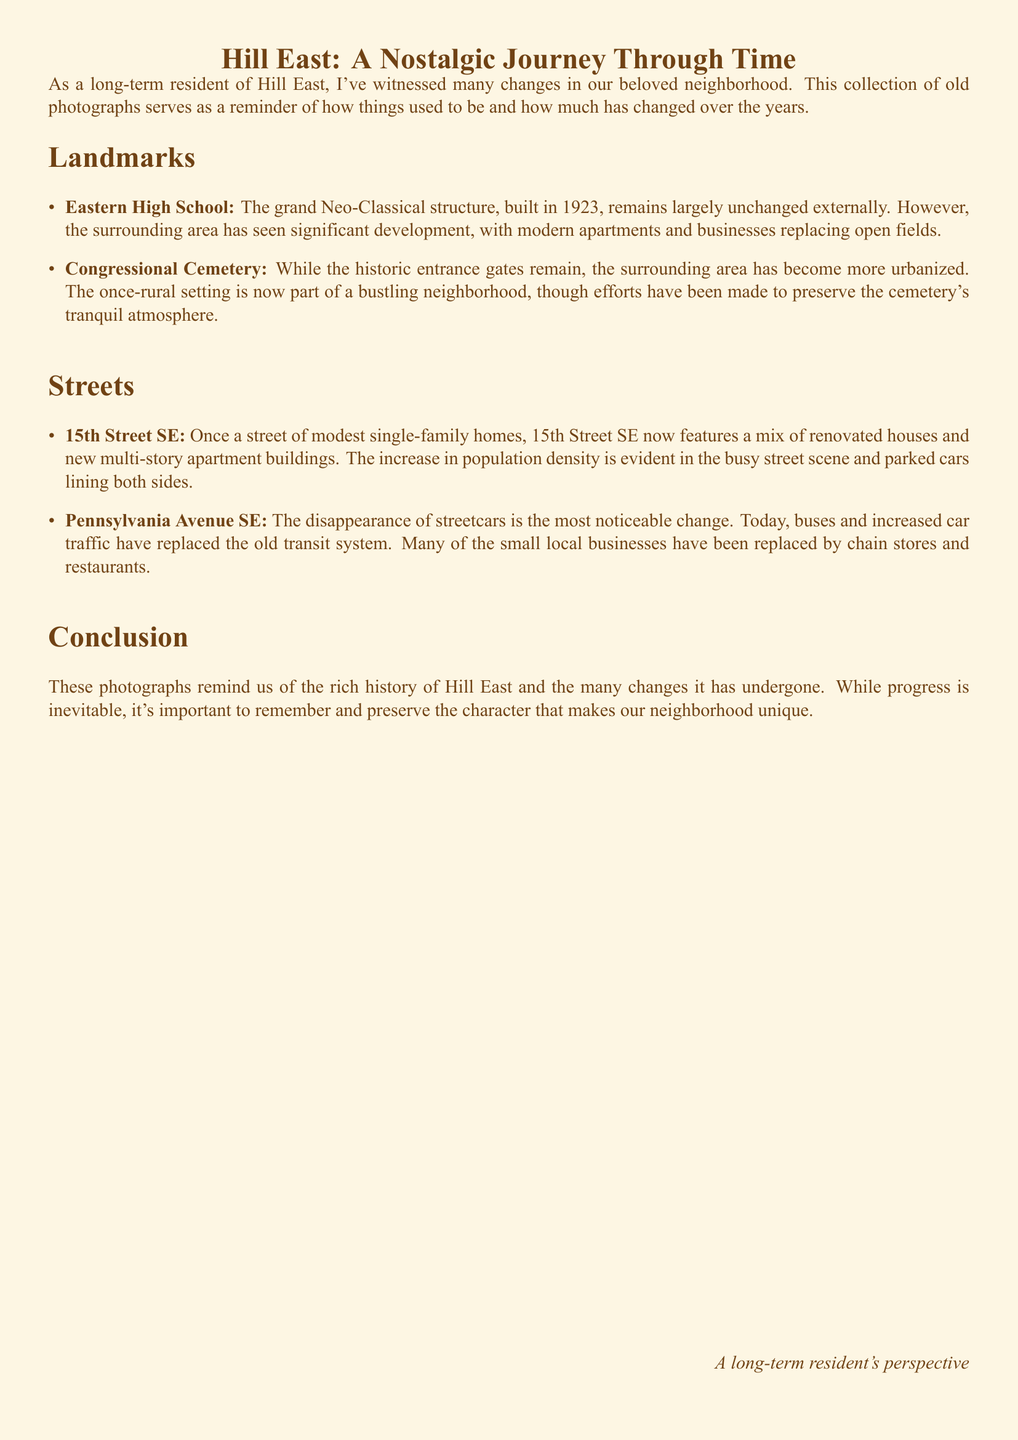What year was Eastern High School built? The document states that Eastern High School was built in 1923.
Answer: 1923 What type of structure is Eastern High School described as? The document describes Eastern High School as a grand Neo-Classical structure.
Answer: Neo-Classical What notable change has occurred around Congressional Cemetery? The surrounding area of Congressional Cemetery has become more urbanized according to the document.
Answer: Urbanized What is mentioned as the most noticeable change on Pennsylvania Avenue SE? The disappearance of streetcars is highlighted as the most noticeable change on Pennsylvania Avenue SE.
Answer: Disappearance of streetcars How was 15th Street SE characterized in the 1950s photograph? The document mentions that 15th Street SE showed a quiet residential street with small houses and few cars in the 1950s photograph.
Answer: Quiet residential street What has replaced the old transit system on Pennsylvania Avenue SE? The document notes that buses and increased car traffic have replaced the old transit system.
Answer: Buses and increased car traffic What is the purpose of the old photographs in the collection? The collection serves as a reminder of how things used to be and how much has changed over the years.
Answer: Reminder of changes Which landmark has made efforts to preserve its tranquil atmosphere? The document states that efforts have been made to preserve the cemetery's tranquil atmosphere around Congressional Cemetery.
Answer: Congressional Cemetery What characterizes the changes on 15th Street SE today? The document mentions that 15th Street SE now features a mix of renovated houses and new multi-story apartment buildings.
Answer: Mix of renovated houses and new multi-story apartment buildings 